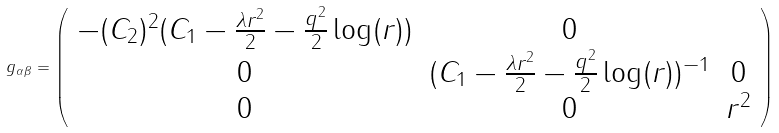Convert formula to latex. <formula><loc_0><loc_0><loc_500><loc_500>g _ { \alpha \beta } = \left ( \begin{array} { c c c } - ( C _ { 2 } ) ^ { 2 } ( C _ { 1 } - \frac { \lambda r ^ { 2 } } { 2 } - \frac { q ^ { 2 } } { 2 } \log ( r ) ) & 0 & \\ 0 & ( C _ { 1 } - \frac { \lambda r ^ { 2 } } { 2 } - \frac { q ^ { 2 } } { 2 } \log ( r ) ) ^ { - 1 } & 0 \\ 0 & 0 & r ^ { 2 } \end{array} \right )</formula> 